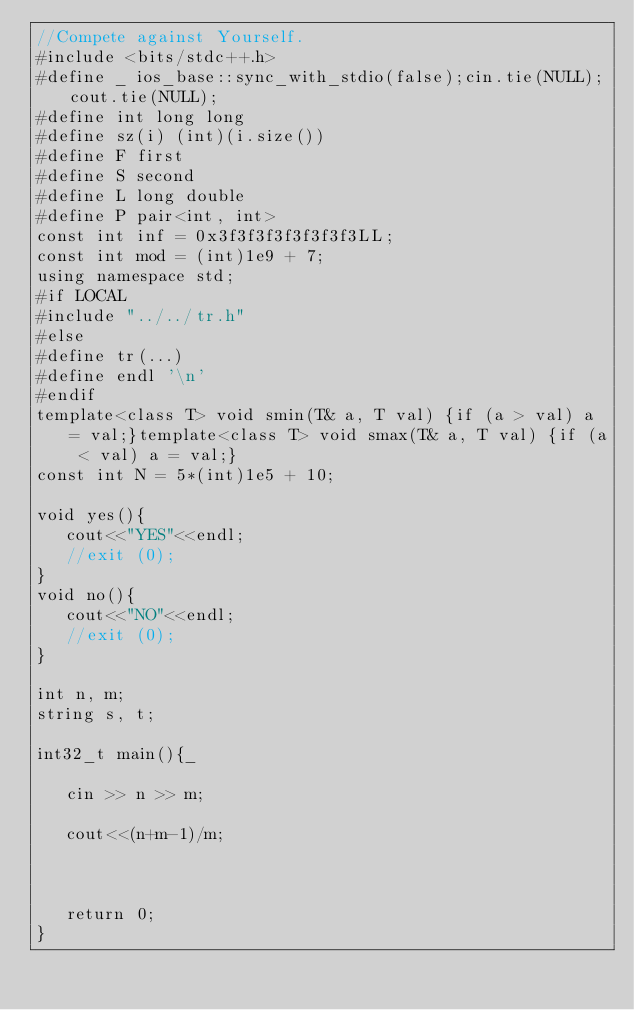Convert code to text. <code><loc_0><loc_0><loc_500><loc_500><_C++_>//Compete against Yourself.
#include <bits/stdc++.h>
#define _ ios_base::sync_with_stdio(false);cin.tie(NULL);cout.tie(NULL);
#define int long long
#define sz(i) (int)(i.size())
#define F first
#define S second
#define L long double
#define P pair<int, int>
const int inf = 0x3f3f3f3f3f3f3f3LL;
const int mod = (int)1e9 + 7;
using namespace std;
#if LOCAL
#include "../../tr.h"
#else
#define tr(...)
#define endl '\n'
#endif
template<class T> void smin(T& a, T val) {if (a > val) a = val;}template<class T> void smax(T& a, T val) {if (a < val) a = val;}
const int N = 5*(int)1e5 + 10;

void yes(){
   cout<<"YES"<<endl;
   //exit (0);
}
void no(){
   cout<<"NO"<<endl;
   //exit (0);   
}

int n, m;
string s, t;

int32_t main(){_
   
   cin >> n >> m;

   cout<<(n+m-1)/m;   



   return 0;
}</code> 